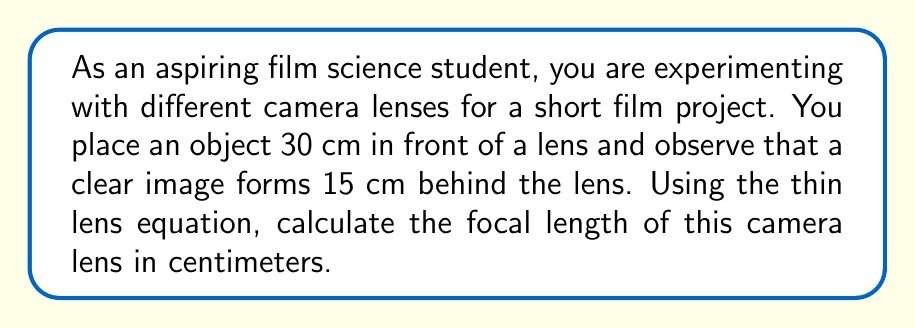Help me with this question. To solve this problem, we'll use the thin lens equation:

$$\frac{1}{f} = \frac{1}{d_o} + \frac{1}{d_i}$$

Where:
$f$ = focal length
$d_o$ = distance from object to lens
$d_i$ = distance from lens to image

Step 1: Identify the given values
$d_o = 30$ cm
$d_i = 15$ cm

Step 2: Substitute these values into the thin lens equation
$$\frac{1}{f} = \frac{1}{30} + \frac{1}{15}$$

Step 3: Find a common denominator (30)
$$\frac{1}{f} = \frac{1}{30} + \frac{2}{30} = \frac{3}{30}$$

Step 4: Simplify
$$\frac{1}{f} = \frac{1}{10}$$

Step 5: Solve for $f$
$$f = 10$$

Therefore, the focal length of the camera lens is 10 cm.
Answer: $f = 10$ cm 